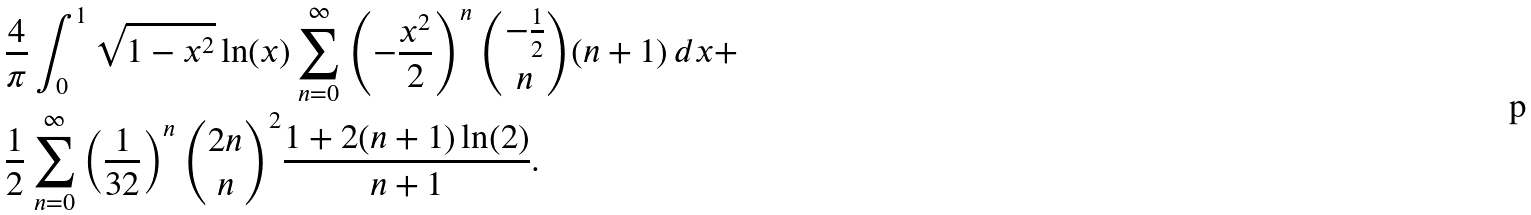<formula> <loc_0><loc_0><loc_500><loc_500>& \frac { 4 } { \pi } \int _ { 0 } ^ { 1 } \sqrt { 1 - x ^ { 2 } } \ln ( x ) \sum _ { n = 0 } ^ { \infty } \left ( - \frac { x ^ { 2 } } { 2 } \right ) ^ { n } \binom { - \frac { 1 } { 2 } } { n } ( n + 1 ) \, d x + \\ & \frac { 1 } { 2 } \sum _ { n = 0 } ^ { \infty } \left ( \frac { 1 } { 3 2 } \right ) ^ { n } \binom { 2 n } { n } ^ { 2 } \frac { 1 + 2 ( n + 1 ) \ln ( 2 ) } { n + 1 } .</formula> 